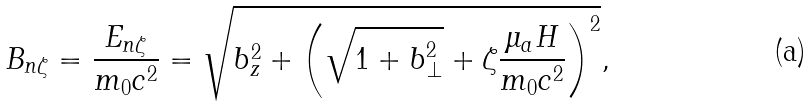Convert formula to latex. <formula><loc_0><loc_0><loc_500><loc_500>B _ { n \zeta } = \frac { E _ { n \zeta } } { m _ { 0 } c ^ { 2 } } = \sqrt { b _ { z } ^ { 2 } + { \left ( \sqrt { 1 + b _ { \perp } ^ { 2 } } + \zeta \frac { \mu _ { a } H } { m _ { 0 } c ^ { 2 } } \right ) } ^ { 2 } } ,</formula> 